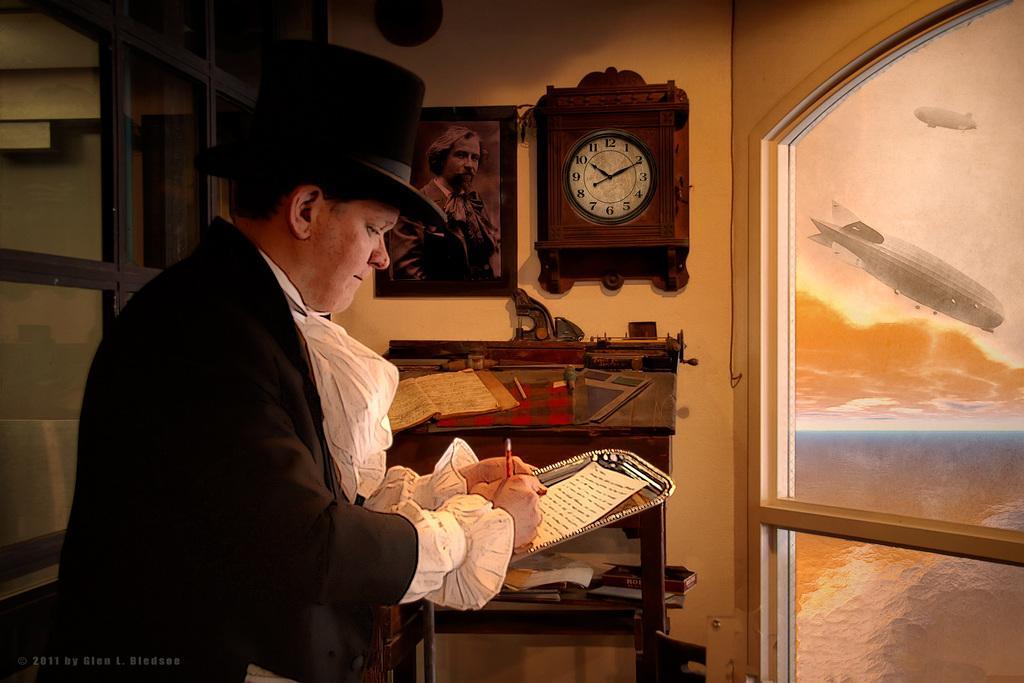Could you give a brief overview of what you see in this image? In this image, we can see a man standing and writing on the paper, in the background there is a wall and we can see a clock and a photo on the wall, on the right side we can see glass windows. 